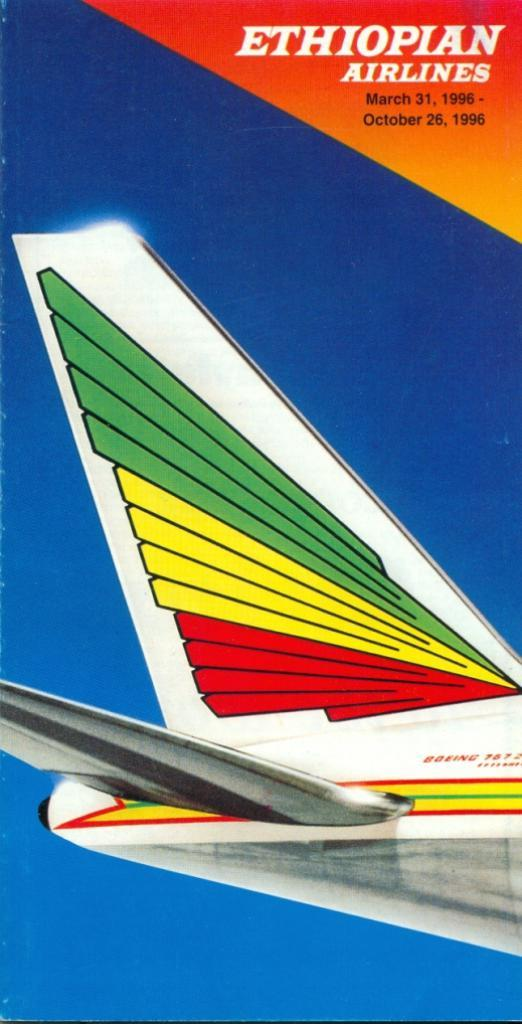<image>
Create a compact narrative representing the image presented. the company Ethiopian Airlines is on the front of a brochure 